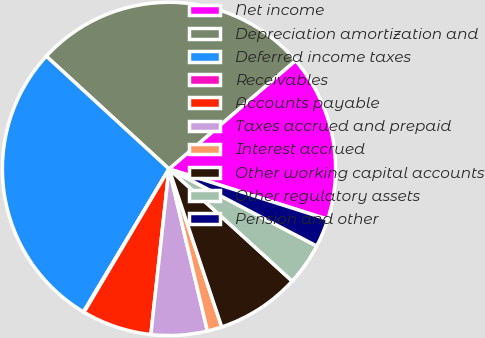<chart> <loc_0><loc_0><loc_500><loc_500><pie_chart><fcel>Net income<fcel>Depreciation amortization and<fcel>Deferred income taxes<fcel>Receivables<fcel>Accounts payable<fcel>Taxes accrued and prepaid<fcel>Interest accrued<fcel>Other working capital accounts<fcel>Other regulatory assets<fcel>Pension and other<nl><fcel>16.17%<fcel>26.9%<fcel>28.24%<fcel>0.07%<fcel>6.78%<fcel>5.44%<fcel>1.42%<fcel>8.12%<fcel>4.1%<fcel>2.76%<nl></chart> 